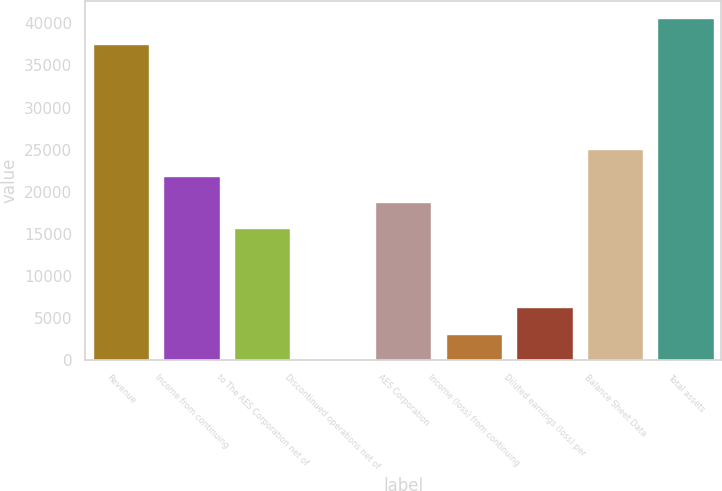Convert chart. <chart><loc_0><loc_0><loc_500><loc_500><bar_chart><fcel>Revenue<fcel>Income from continuing<fcel>to The AES Corporation net of<fcel>Discontinued operations net of<fcel>AES Corporation<fcel>Income (loss) from continuing<fcel>Diluted earnings (loss) per<fcel>Balance Sheet Data<fcel>Total assets<nl><fcel>37528.8<fcel>21891.9<fcel>15637.1<fcel>0.15<fcel>18764.5<fcel>3127.54<fcel>6254.93<fcel>25019.2<fcel>40656.2<nl></chart> 